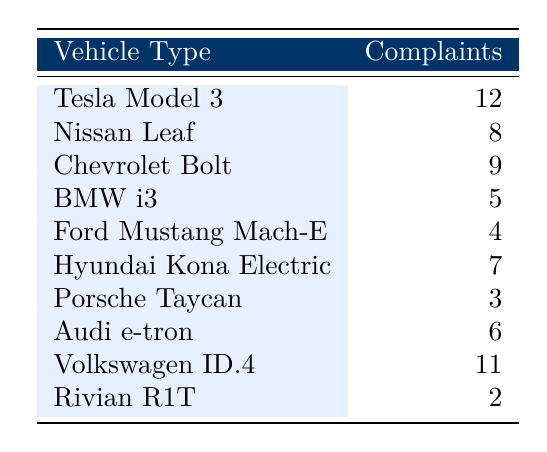What is the total number of complaints for all vehicle types? To find the total complaints, we add up all the complaints from each vehicle type: 12 + 8 + 9 + 5 + 4 + 7 + 3 + 6 + 11 + 2 = 67.
Answer: 67 Which vehicle type received the highest number of complaints? Looking at the complaints listed in the table, the Tesla Model 3 has the highest number of complaints at 12.
Answer: Tesla Model 3 How many complaints were made about the Volkswagen ID.4? The table indicates that there were 11 complaints registered for the Volkswagen ID.4.
Answer: 11 Is there a vehicle type that received exactly 6 complaints? Checking the table, the Audi e-tron received exactly 6 complaints.
Answer: Yes What is the average number of complaints for the vehicle types listed? To calculate the average, we take the total number of complaints (67) and divide it by the number of vehicle types (10): 67 / 10 = 6.7.
Answer: 6.7 How many more complaints did the Tesla Model 3 receive compared to the Ford Mustang Mach-E? The Tesla Model 3 received 12 complaints while the Ford Mustang Mach-E received 4. The difference is 12 - 4 = 8.
Answer: 8 What percentage of the total complaints were for Nissan Leaf? The Nissan Leaf had 8 complaints. To find the percentage, we calculate (8 / 67) * 100 = approximately 11.94%.
Answer: Approximately 11.94% Which two vehicle types had the least number of complaints, and what is their combined total? The Rivian R1T (2 complaints) and the Ford Mustang Mach-E (4 complaints) had the least complaints. Their combined total is 2 + 4 = 6 complaints.
Answer: 6 How many vehicle types received 8 or more complaints? The vehicle types with 8 or more complaints are the Tesla Model 3, Nissan Leaf, Chevrolet Bolt, Volkswagen ID.4, which totals to 4.
Answer: 4 